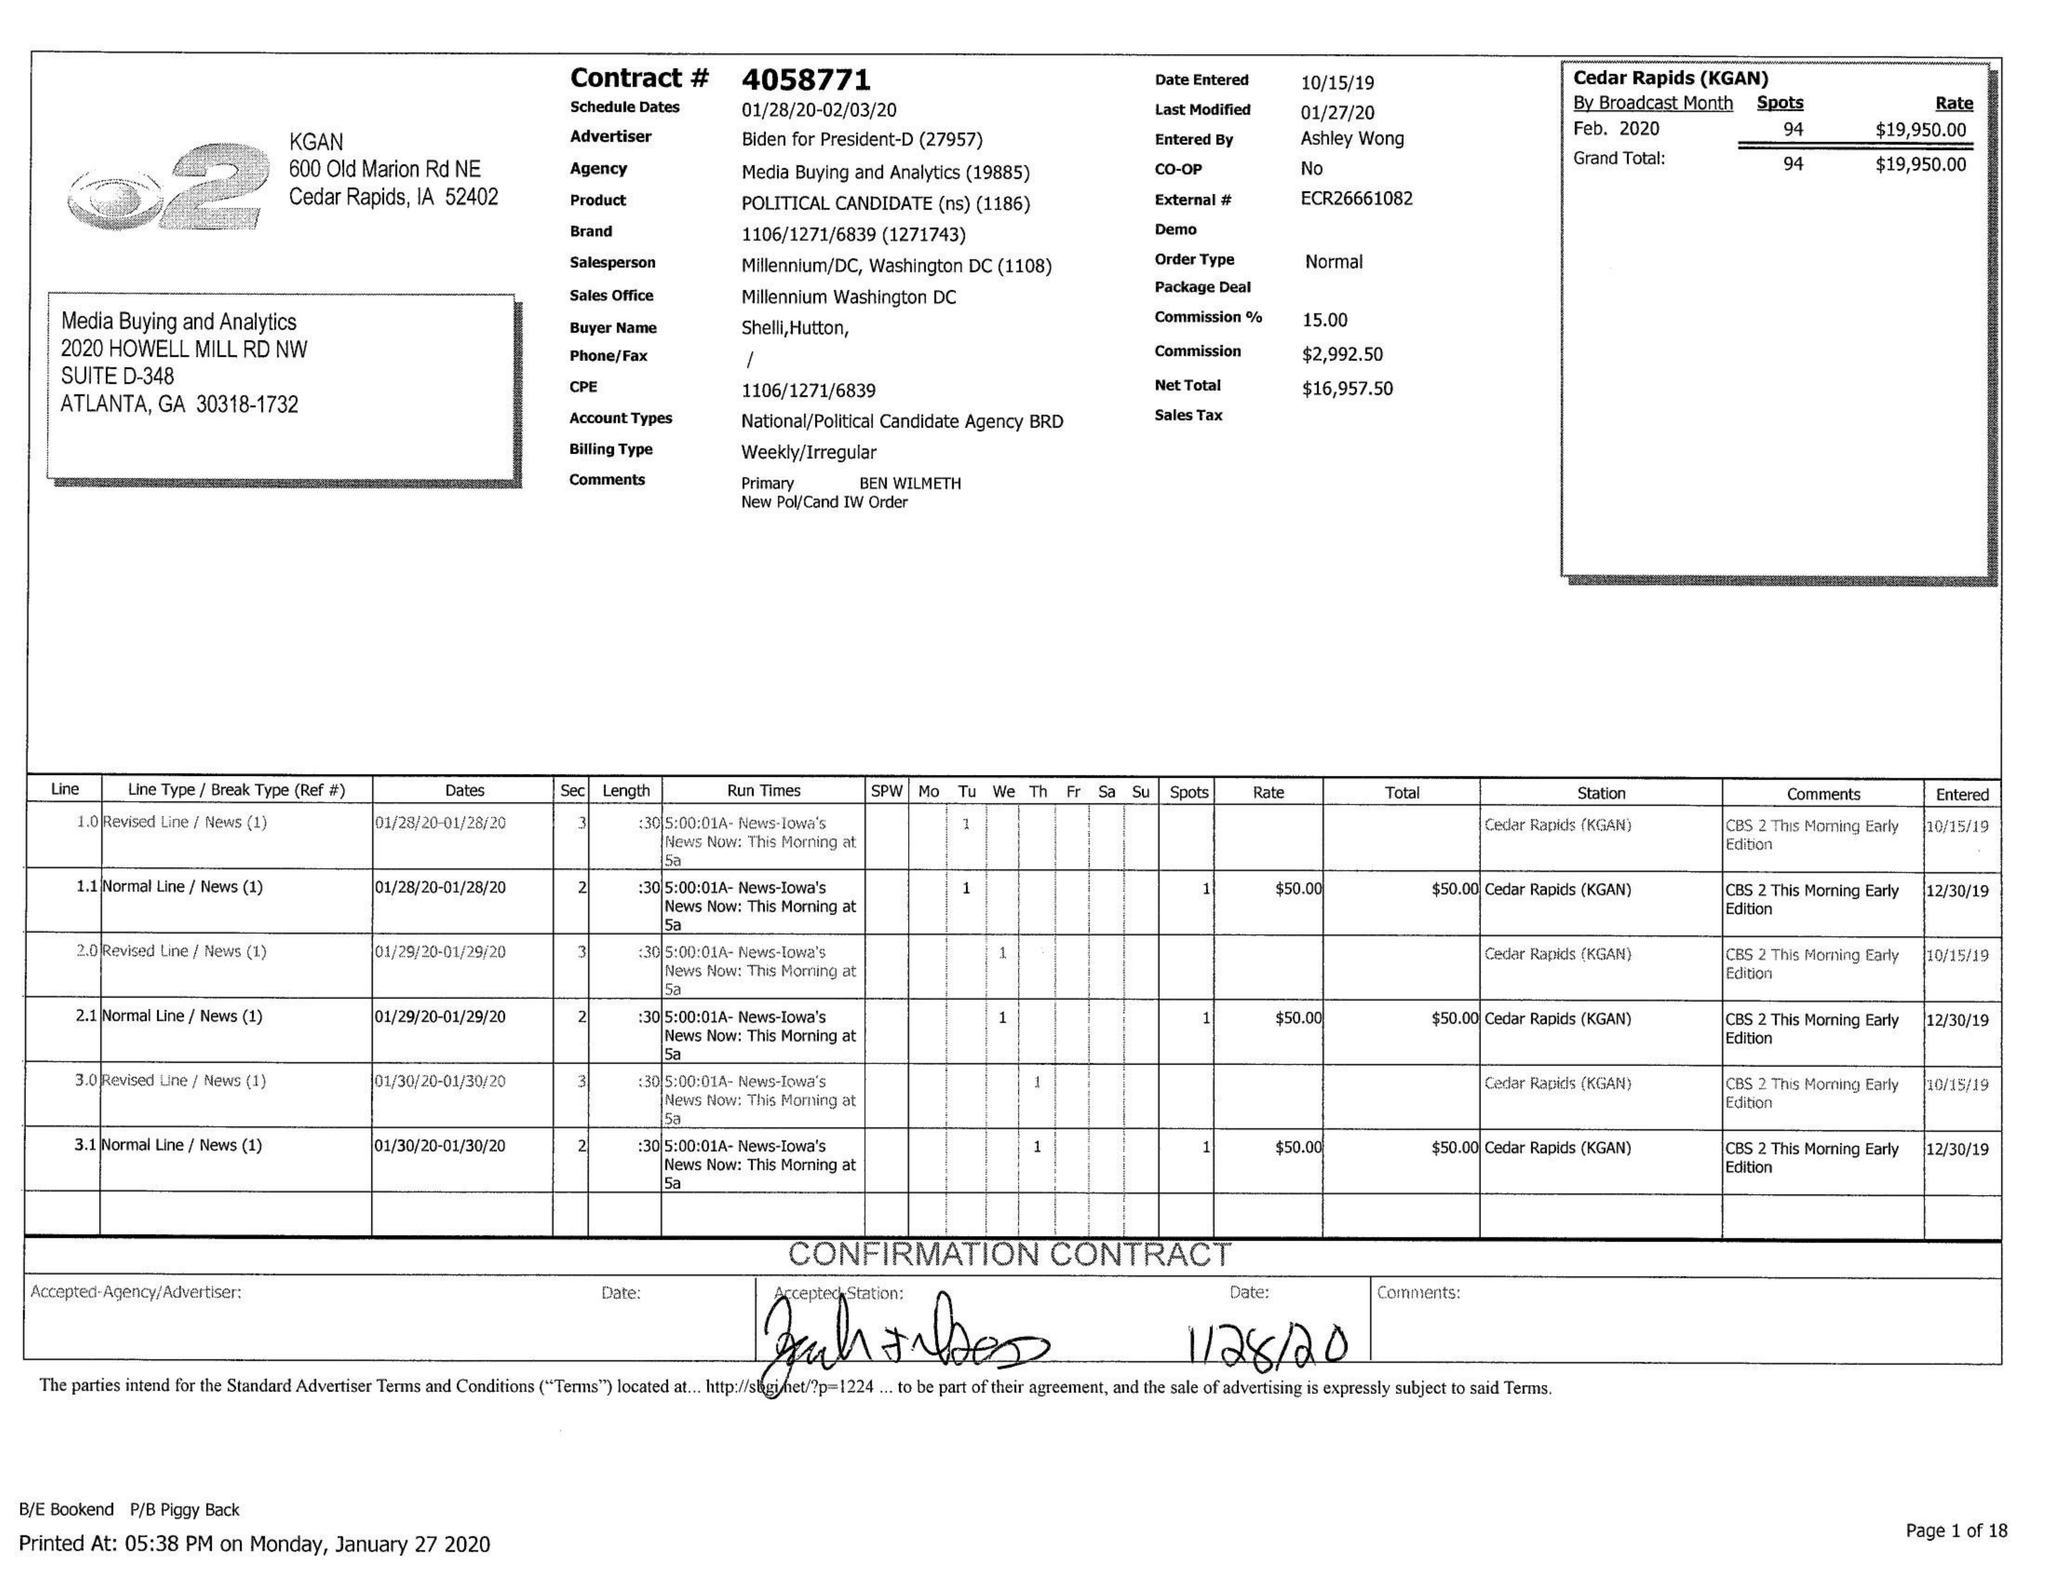What is the value for the gross_amount?
Answer the question using a single word or phrase. 19950.00 